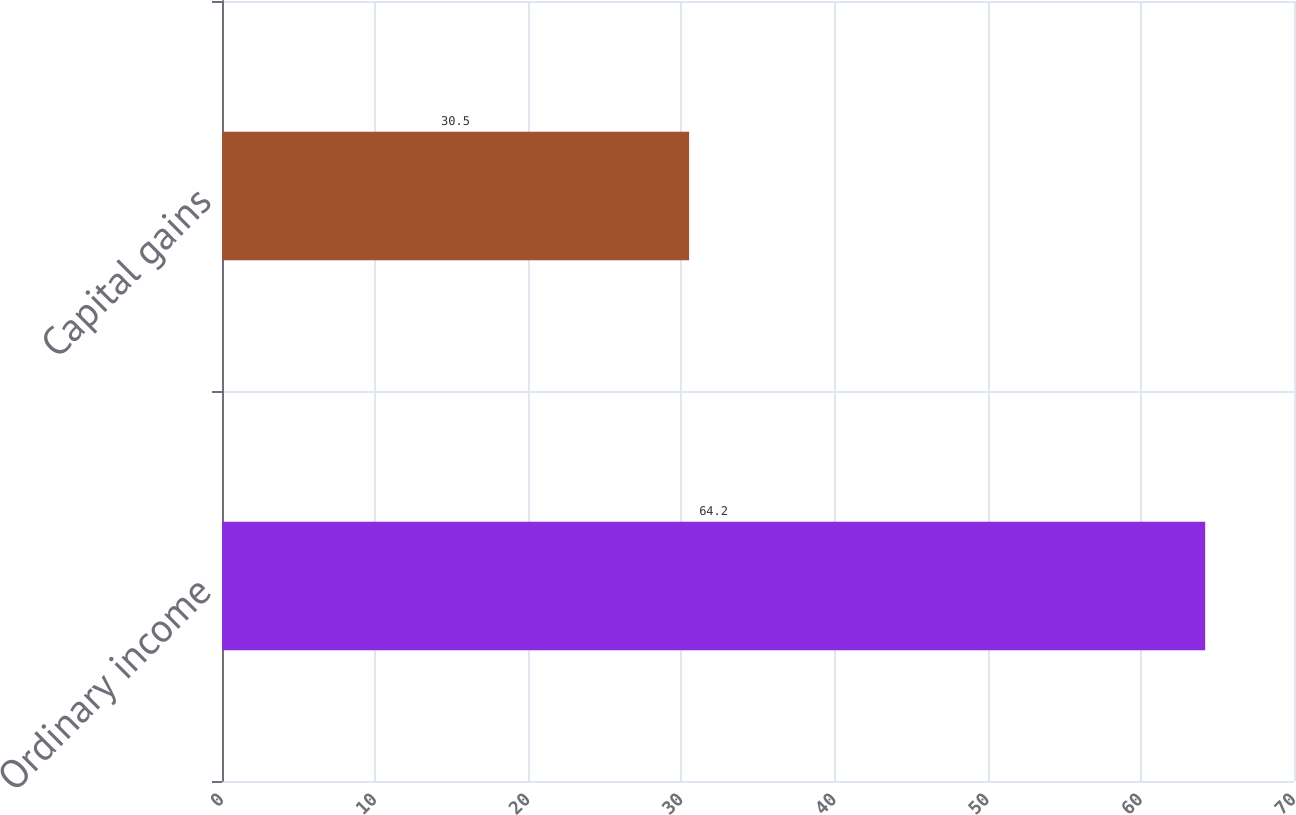<chart> <loc_0><loc_0><loc_500><loc_500><bar_chart><fcel>Ordinary income<fcel>Capital gains<nl><fcel>64.2<fcel>30.5<nl></chart> 